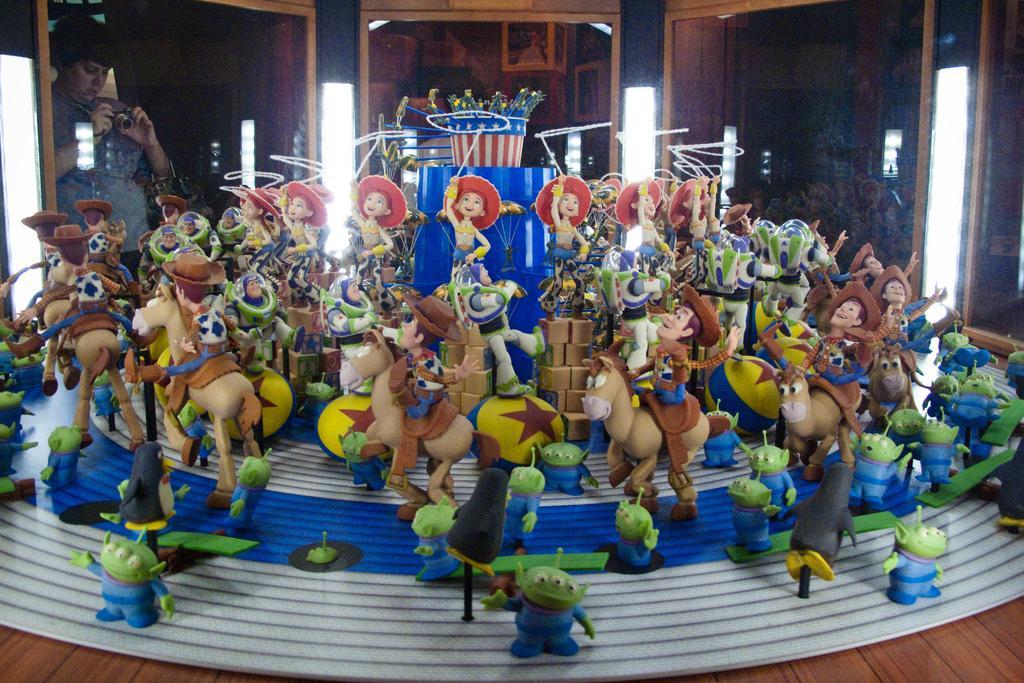Can you describe this image briefly? In this image we can see toys on the surface, on the left we can see one person standing and holding a camera, we can see glass windows, we can see photo frames on the wooden wall. 